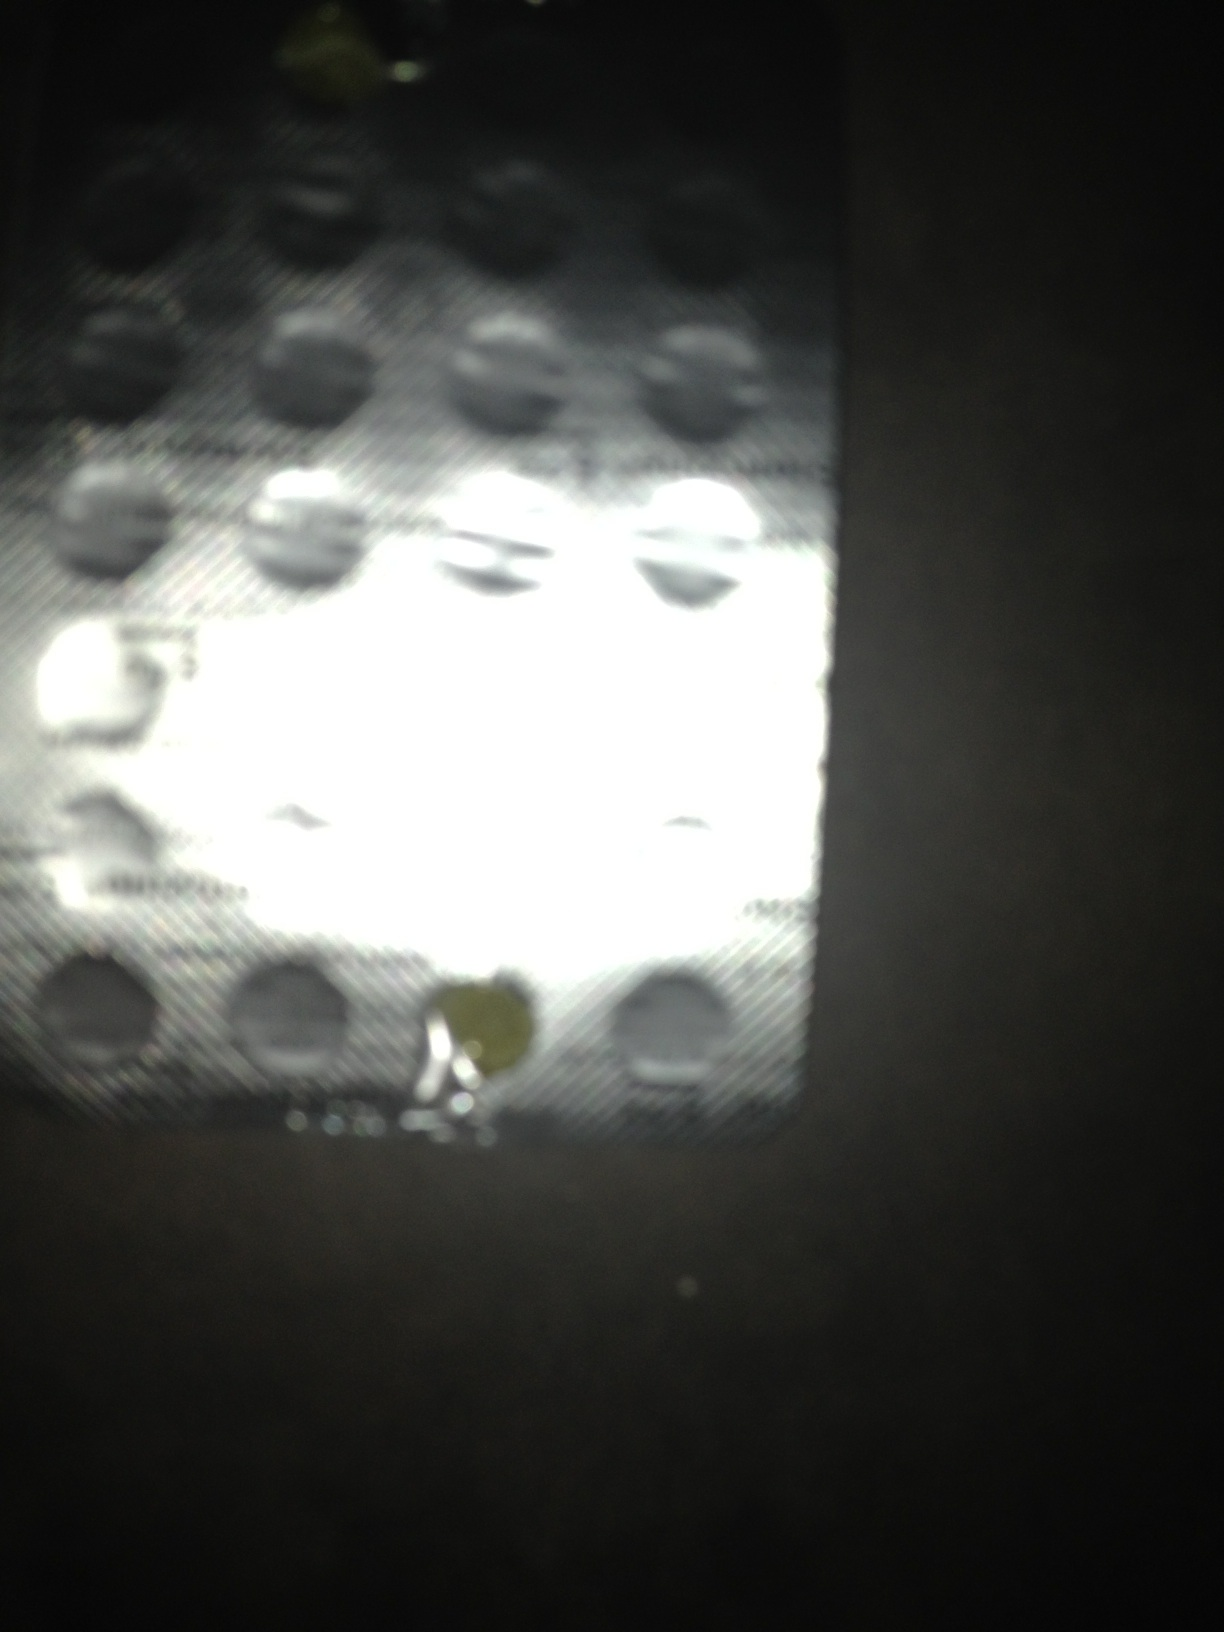Is there a general guideline on how to dispose of medications like these safely? Yes, to safely dispose of medications, check if your pharmacy has a take-back program. Alternatively, you can mix the medication with an undesirable substance like used coffee grounds or cat litter, place it in a sealed plastic bag, and throw it away in your household trash. Be sure to scratch out all personal information on the prescription label to protect your privacy. 